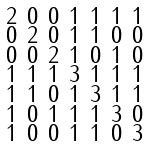Convert formula to latex. <formula><loc_0><loc_0><loc_500><loc_500>\begin{smallmatrix} 2 & 0 & 0 & 1 & 1 & 1 & 1 \\ 0 & 2 & 0 & 1 & 1 & 0 & 0 \\ 0 & 0 & 2 & 1 & 0 & 1 & 0 \\ 1 & 1 & 1 & 3 & 1 & 1 & 1 \\ 1 & 1 & 0 & 1 & 3 & 1 & 1 \\ 1 & 0 & 1 & 1 & 1 & 3 & 0 \\ 1 & 0 & 0 & 1 & 1 & 0 & 3 \end{smallmatrix}</formula> 